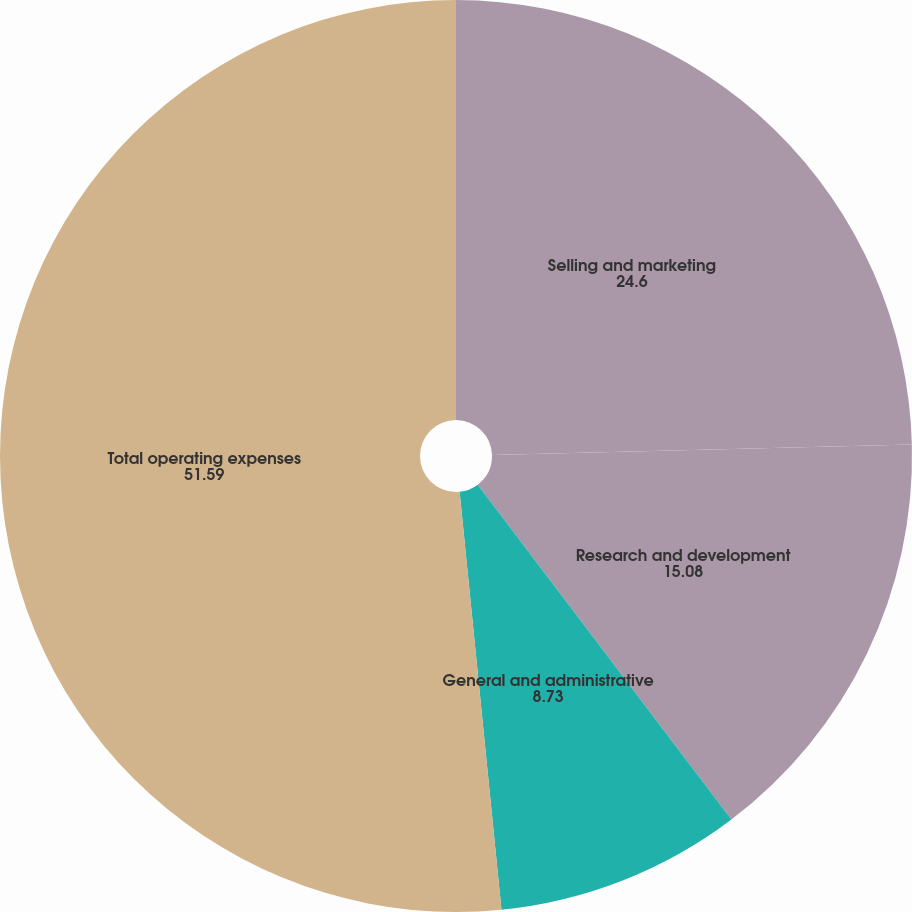Convert chart to OTSL. <chart><loc_0><loc_0><loc_500><loc_500><pie_chart><fcel>Selling and marketing<fcel>Research and development<fcel>General and administrative<fcel>Total operating expenses<nl><fcel>24.6%<fcel>15.08%<fcel>8.73%<fcel>51.59%<nl></chart> 